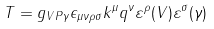<formula> <loc_0><loc_0><loc_500><loc_500>T = g _ { V P \gamma } \epsilon _ { \mu \nu \rho \sigma } k ^ { \mu } q ^ { \nu } \varepsilon ^ { \rho } ( V ) \varepsilon ^ { \sigma } ( \gamma )</formula> 